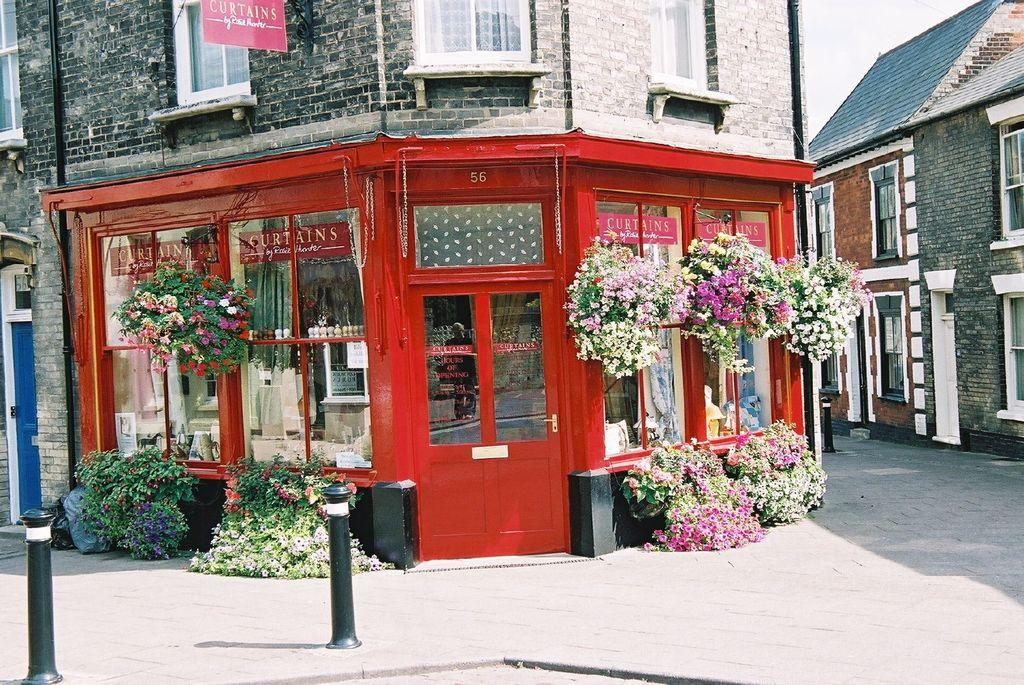What structures can be seen in the image? There are poles in the structures in the form of poles in the image. What type of vegetation is present in the image? There are plants and flowers in the image. What can be seen in the background of the image? There are houses and a footpath in the background of the image. Where is the waste disposal area located in the image? There is no waste disposal area present in the image. What type of ground is visible in the image? The ground is not explicitly visible in the image, as the focus is on the poles, plants, flowers, houses, and footpath. 